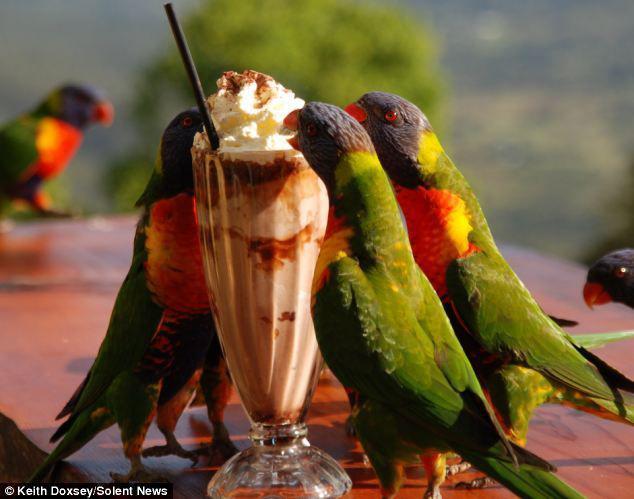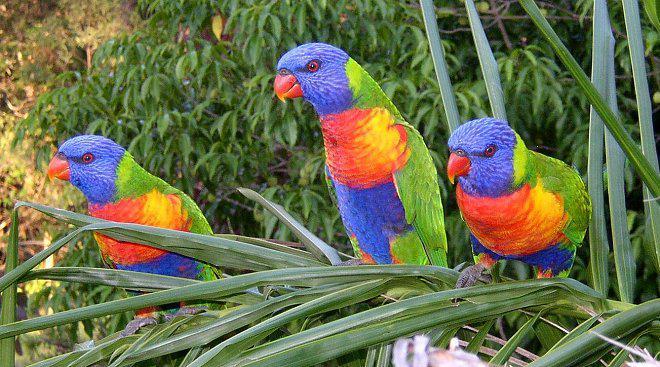The first image is the image on the left, the second image is the image on the right. Evaluate the accuracy of this statement regarding the images: "The left image contains at least three parrots.". Is it true? Answer yes or no. Yes. The first image is the image on the left, the second image is the image on the right. Evaluate the accuracy of this statement regarding the images: "All birds have blue heads and are perched on a branch.". Is it true? Answer yes or no. No. 